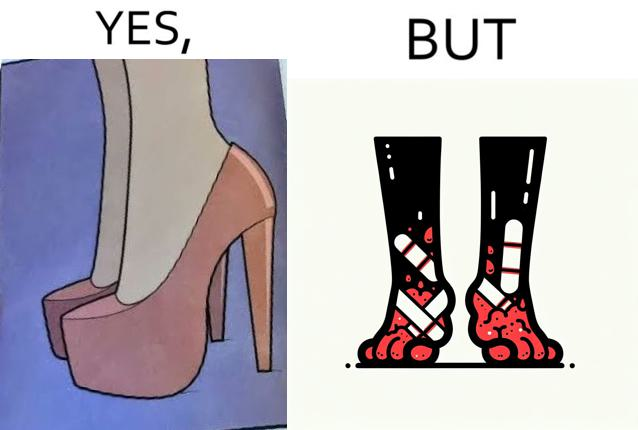Describe what you see in this image. The images are funny since they show how the prettiest footwears like high heels, end up causing a lot of physical discomfort to the user, all in the name fashion 